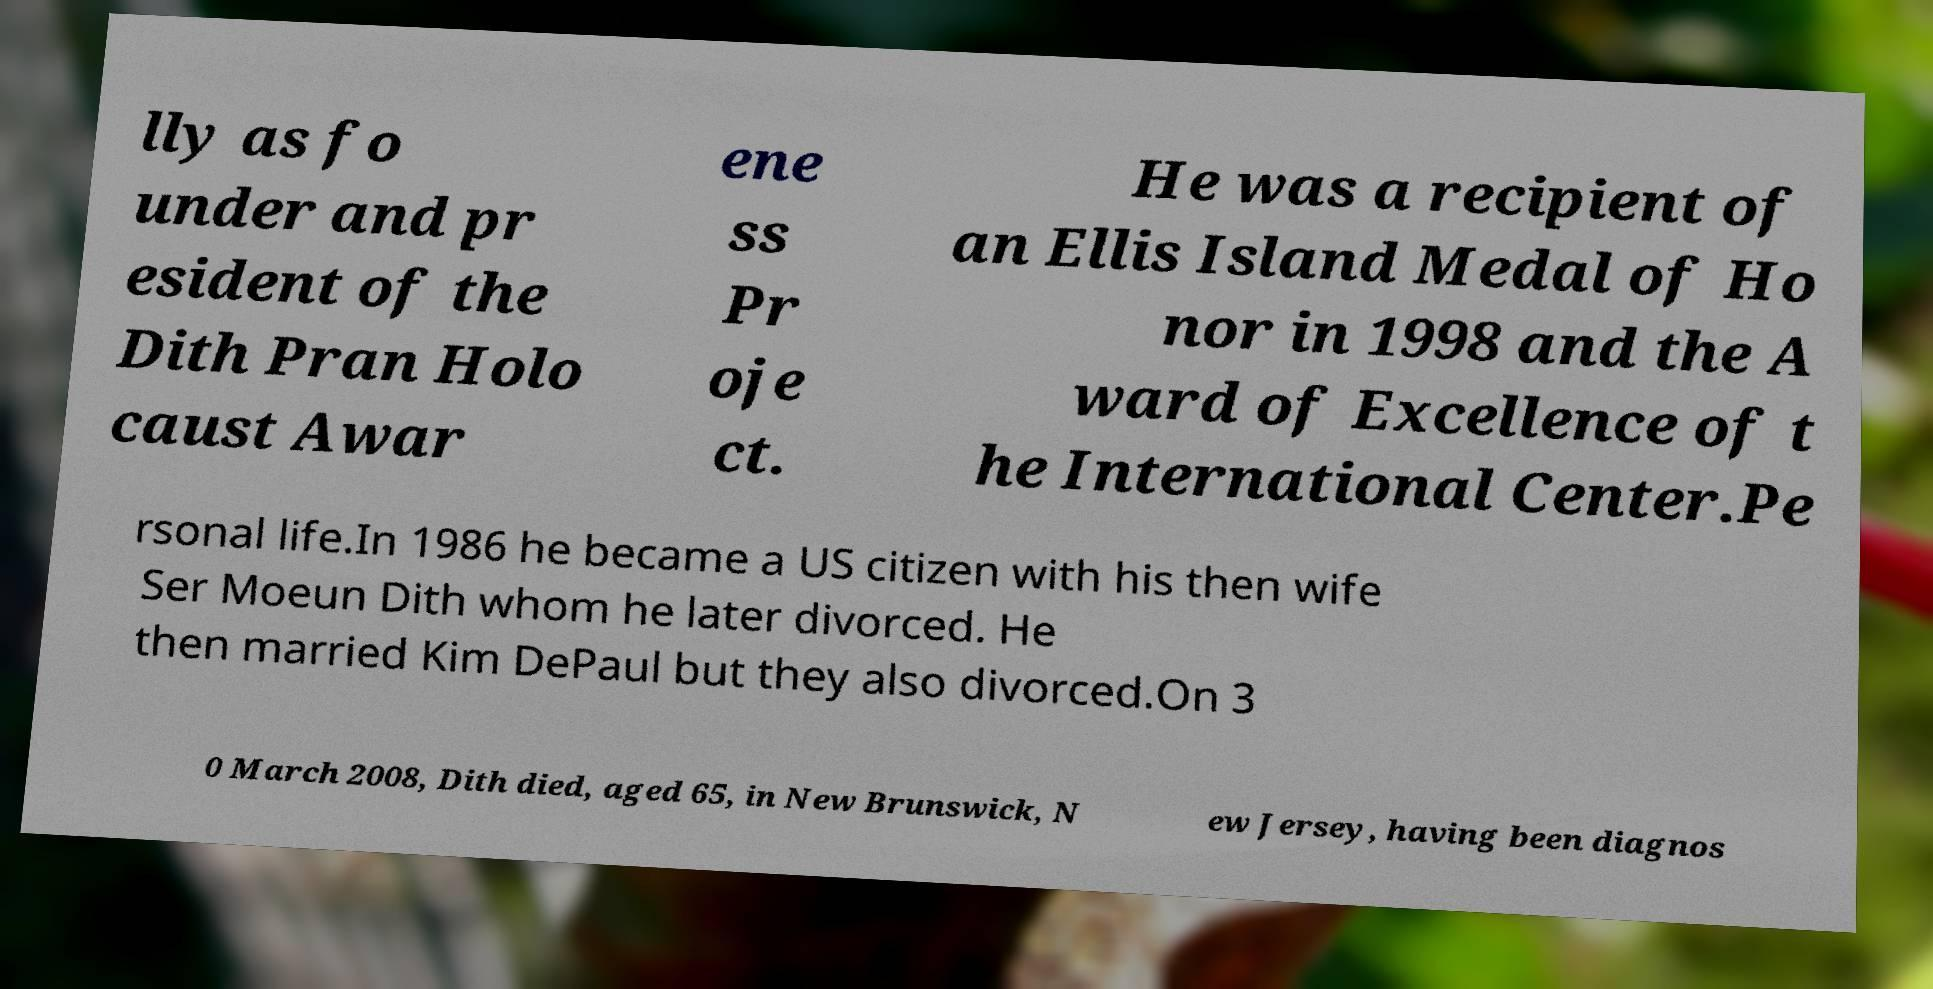What messages or text are displayed in this image? I need them in a readable, typed format. lly as fo under and pr esident of the Dith Pran Holo caust Awar ene ss Pr oje ct. He was a recipient of an Ellis Island Medal of Ho nor in 1998 and the A ward of Excellence of t he International Center.Pe rsonal life.In 1986 he became a US citizen with his then wife Ser Moeun Dith whom he later divorced. He then married Kim DePaul but they also divorced.On 3 0 March 2008, Dith died, aged 65, in New Brunswick, N ew Jersey, having been diagnos 